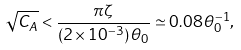Convert formula to latex. <formula><loc_0><loc_0><loc_500><loc_500>\sqrt { C _ { A } } < \frac { \pi \zeta } { ( 2 \times 1 0 ^ { - 3 } ) \, \theta _ { 0 } } \simeq 0 . 0 8 \, \theta _ { 0 } ^ { - 1 } ,</formula> 